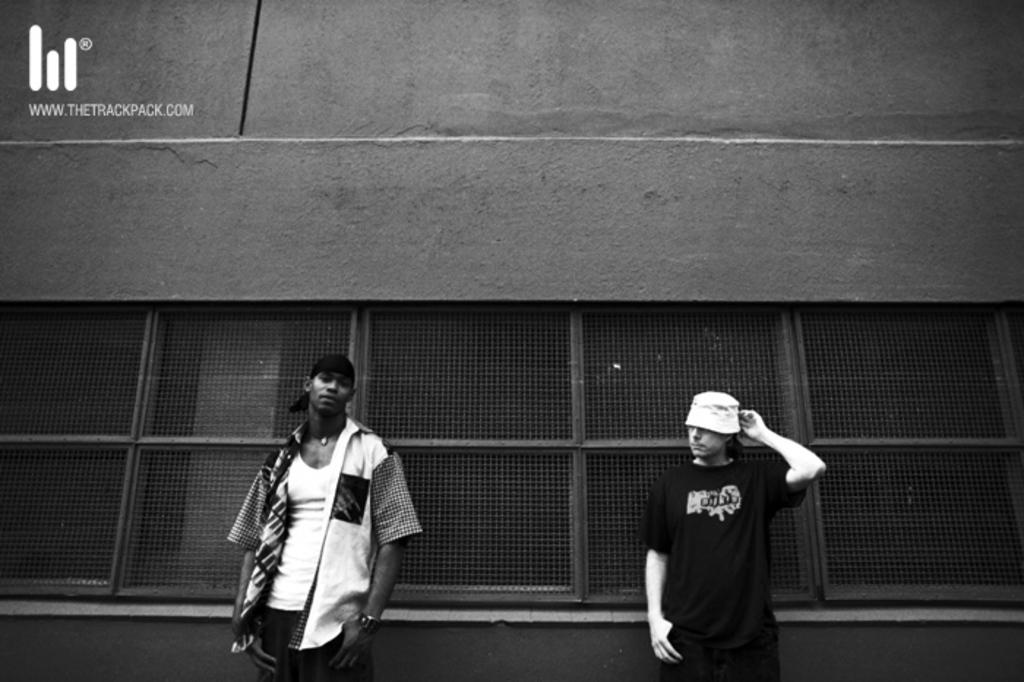What is present in the background of the image? There is a wall in the image. How many people are visible in the image? There are two people standing in the image. What type of hat is the person on the left wearing in the image? There is no hat visible in the image; both people are not wearing any headwear. 